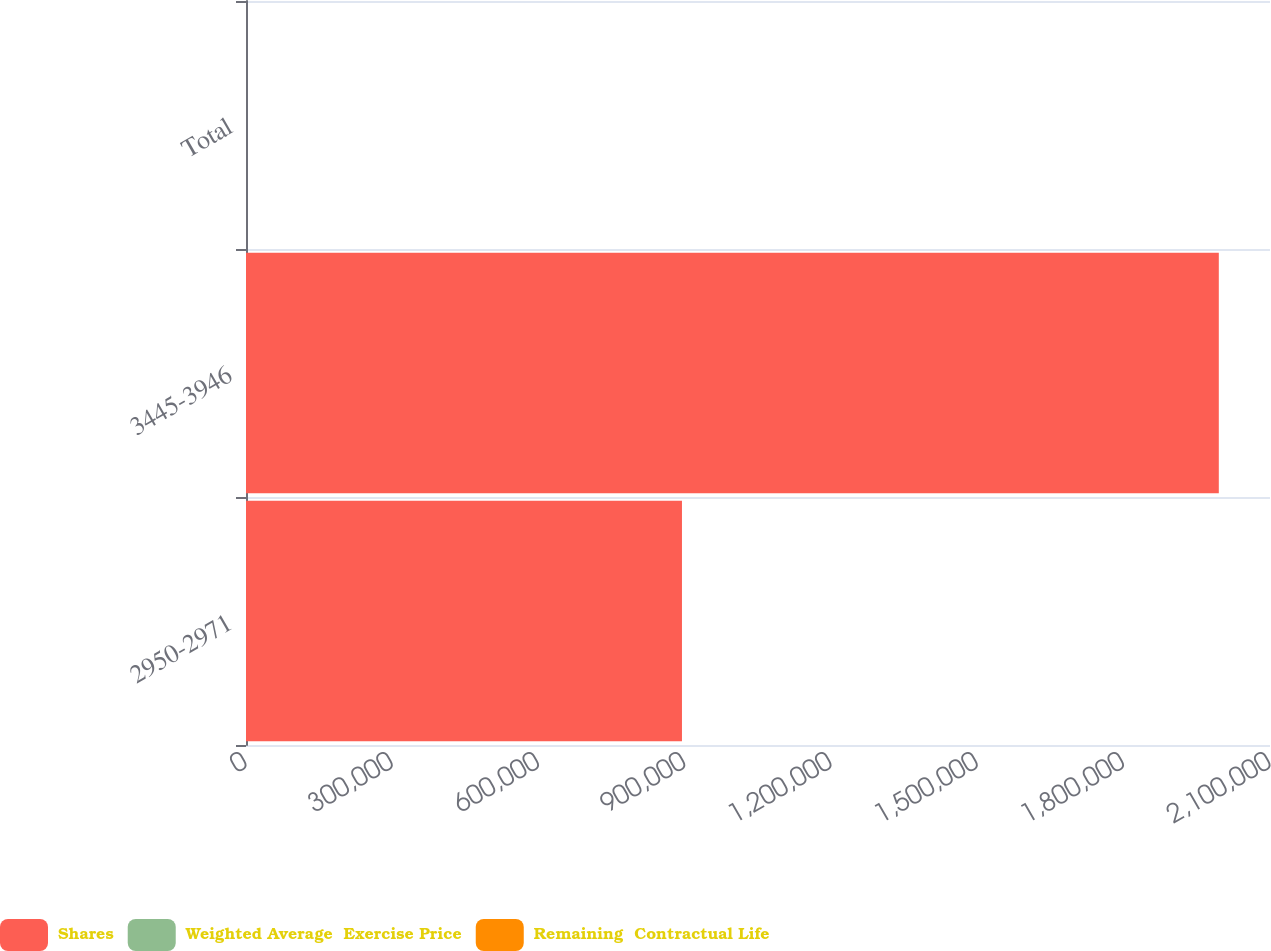Convert chart. <chart><loc_0><loc_0><loc_500><loc_500><stacked_bar_chart><ecel><fcel>2950-2971<fcel>3445-3946<fcel>Total<nl><fcel>Shares<fcel>894054<fcel>1.99501e+06<fcel>32.42<nl><fcel>Weighted Average  Exercise Price<fcel>29.66<fcel>37.66<fcel>35.18<nl><fcel>Remaining  Contractual Life<fcel>1.77<fcel>2.67<fcel>2.39<nl></chart> 